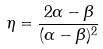<formula> <loc_0><loc_0><loc_500><loc_500>\eta = \frac { 2 \alpha - \beta } { ( \alpha - \beta ) ^ { 2 } }</formula> 